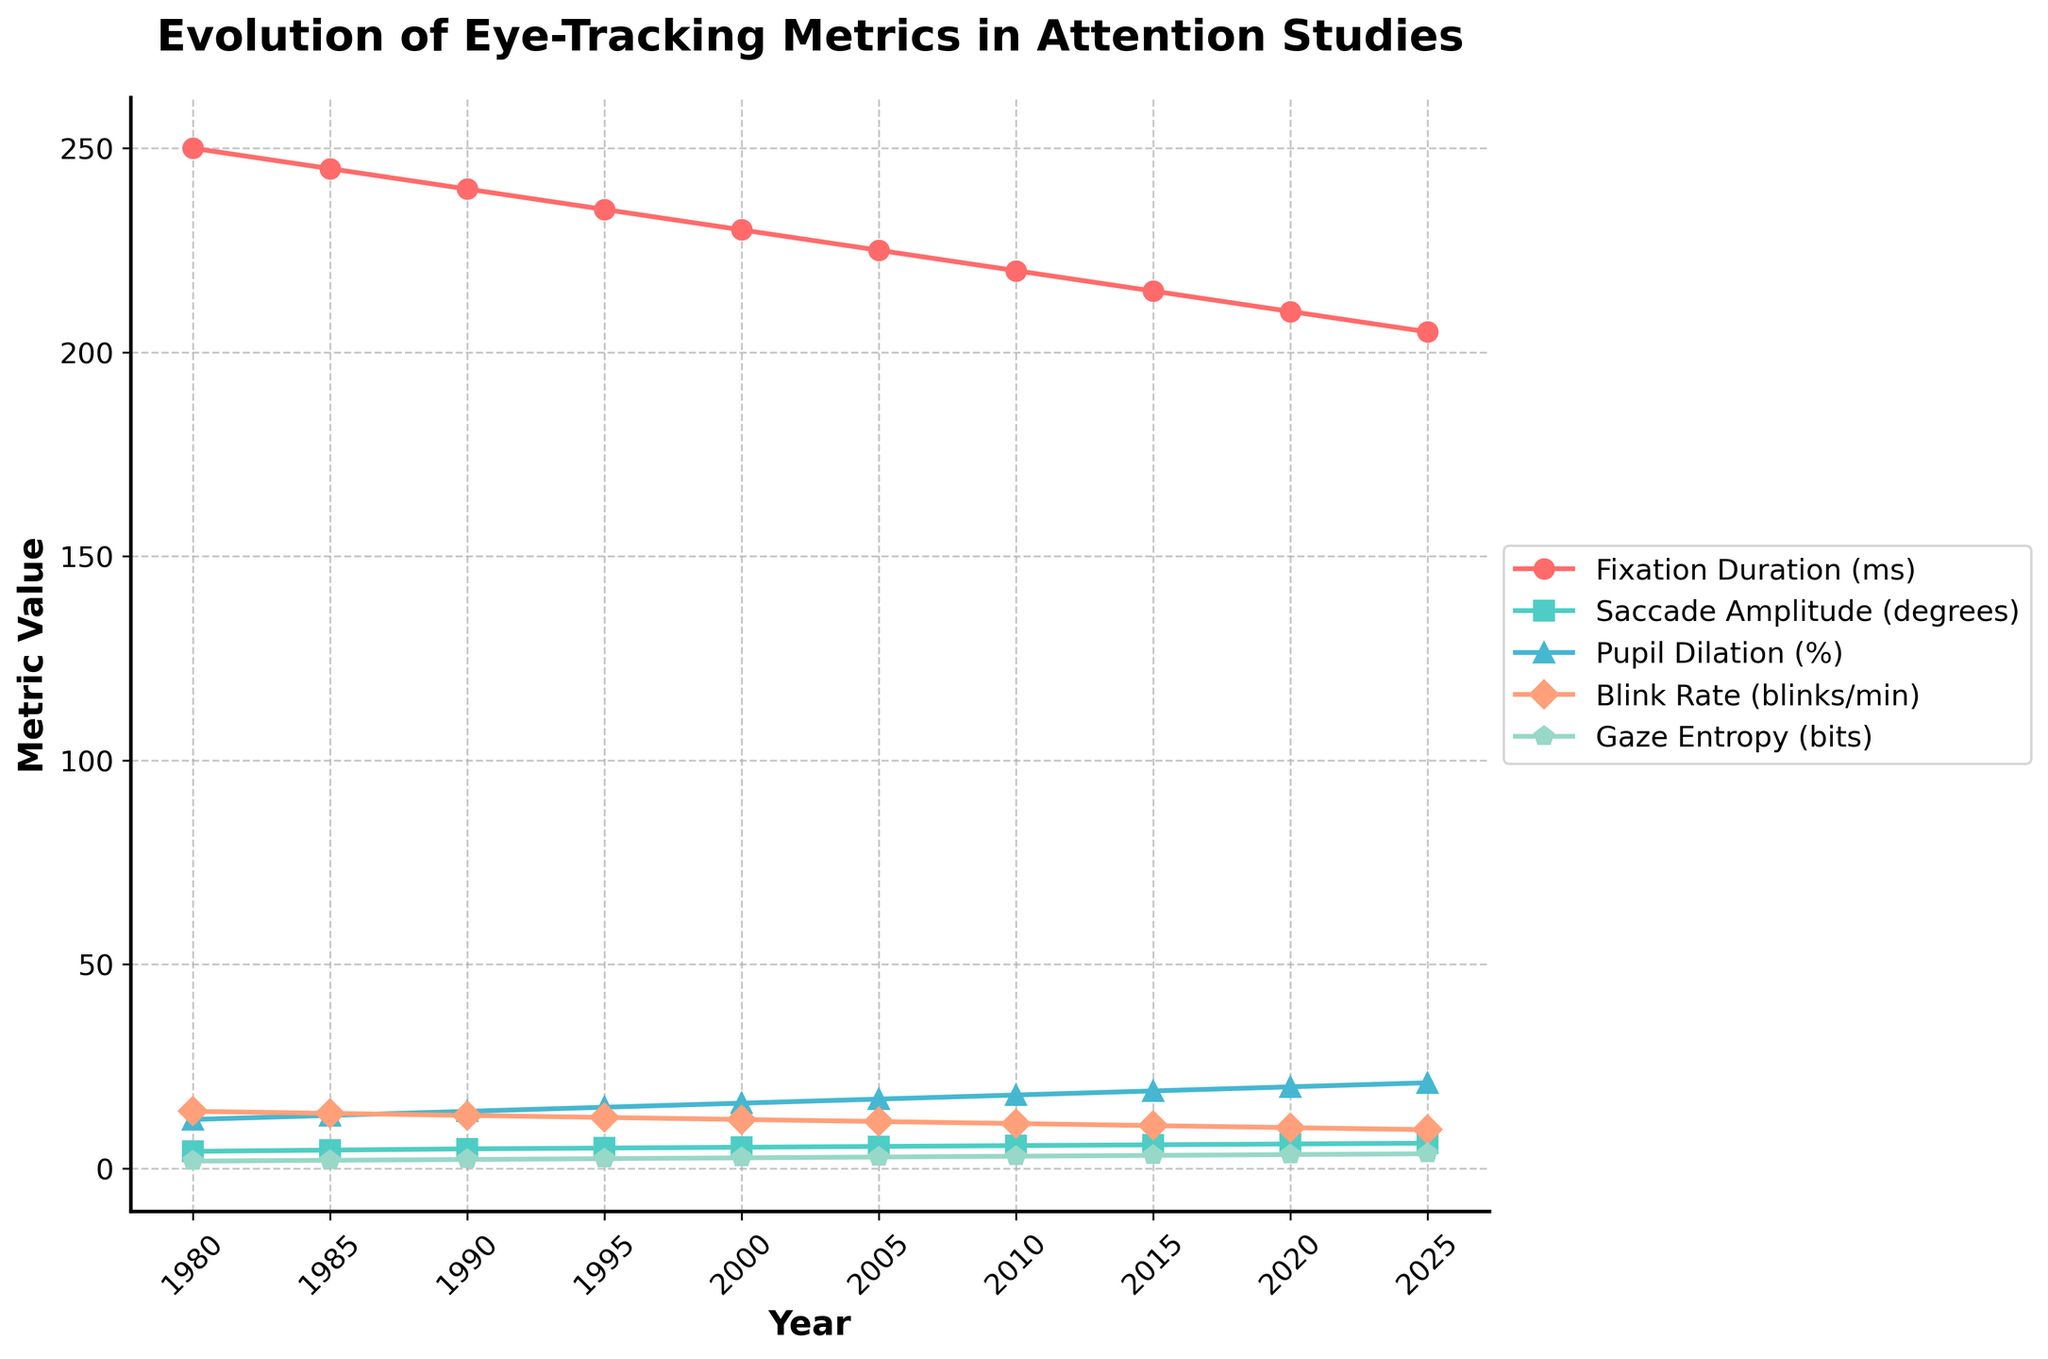What trend is observed in the fixation duration from 1980 to 2025? The line representing fixation duration shows a consistent downward trend over the years. Starting from 250 ms in 1980, it decreases steadily to 205 ms by 2025.
Answer: It decreases What is the general trend in pupil dilation between 1980 and 2025? The line showcasing pupil dilation indicates an upward trend, starting at 12% in 1980 and increasing steadily to 21% by 2025.
Answer: It increases Which year shows the highest value for gaze entropy, and what is that value? The highest value for gaze entropy is found at the endpoint of the line representing gaze entropy, which is in 2025, at a value of 3.6 bits.
Answer: 2025, 3.6 bits Compare the blink rate between 1980 and 2020. The blink rate in 1980 was 14 blinks/min, while in 2020 it decreased to 10 blinks/min. This shows a decline of 4 blinks/min over 40 years.
Answer: 1980: 14, 2020: 10, decline of 4 What is the percentage increase in saccade amplitude from 1980 to 2025? In 1980, the saccade amplitude was 4.2 degrees. By 2025, it increased to 6.2 degrees. The percentage increase is calculated as ((6.2 - 4.2) / 4.2) * 100 = 47.62%.
Answer: 47.62% Which metric shows the most consistent linear trend over the years and why? Gaze entropy shows the most consistent linear trend because its increase appears to be steady and linear over time without any major deviations, as illustrated by the evenly spaced points and consistent slope.
Answer: Gaze entropy Between 1995 and 2005, which metric shows the greatest change? The fixation duration decreases from 235 ms in 1995 to 225 ms in 2005, a change of 10 ms. The saccade amplitude increases from 5.0 to 5.4 degrees, a change of 0.4 degrees. Pupil dilation increases from 15% to 17%, a change of 2%. Blink rate decreases from 12.5 to 11.5 blinks/min, a change of 1 blink/min. Gaze entropy increases from 2.4 to 2.8 bits, a change of 0.4 bits. Therefore, the pupil dilation shows the greatest change.
Answer: Pupil dilation, change of 2% What's the average fixation duration over the decades presented? The fixation durations over the decades are 250, 245, 240, 235, 230, 225, 220, 215, 210, and 205 ms. Summing these gives 2265 ms, divided by 10 years results in an average of 226.5 ms.
Answer: 226.5 ms From the visual attributes of the chart, which metric is represented by the green line, and what does this signify? The green line corresponds to the saccade amplitude metric. This signifies that across the decades, saccade amplitude has been steadily increasing.
Answer: Saccade amplitude In which decade does the blink rate trend change its steepness most noticeably? Observing the blink rate line, the most noticeable change in steepness occurs between 2000 and 2005, where the rate of decline accelerates compared to previous years.
Answer: 2000-2005 